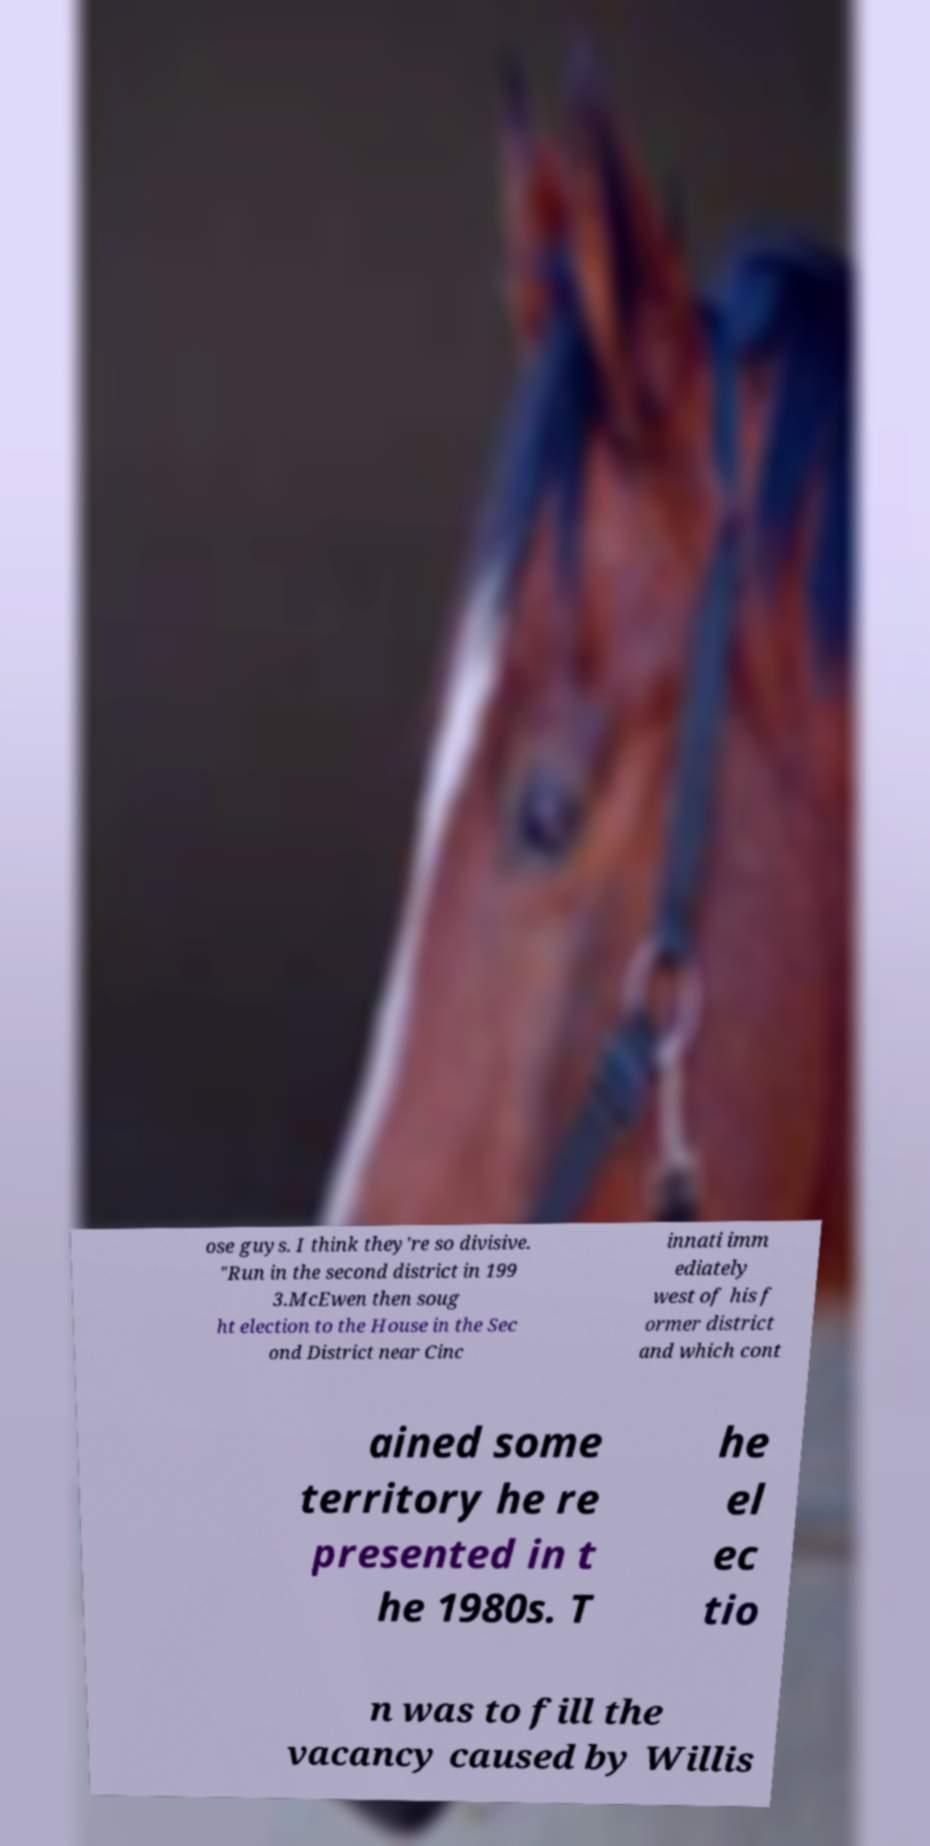I need the written content from this picture converted into text. Can you do that? ose guys. I think they're so divisive. "Run in the second district in 199 3.McEwen then soug ht election to the House in the Sec ond District near Cinc innati imm ediately west of his f ormer district and which cont ained some territory he re presented in t he 1980s. T he el ec tio n was to fill the vacancy caused by Willis 